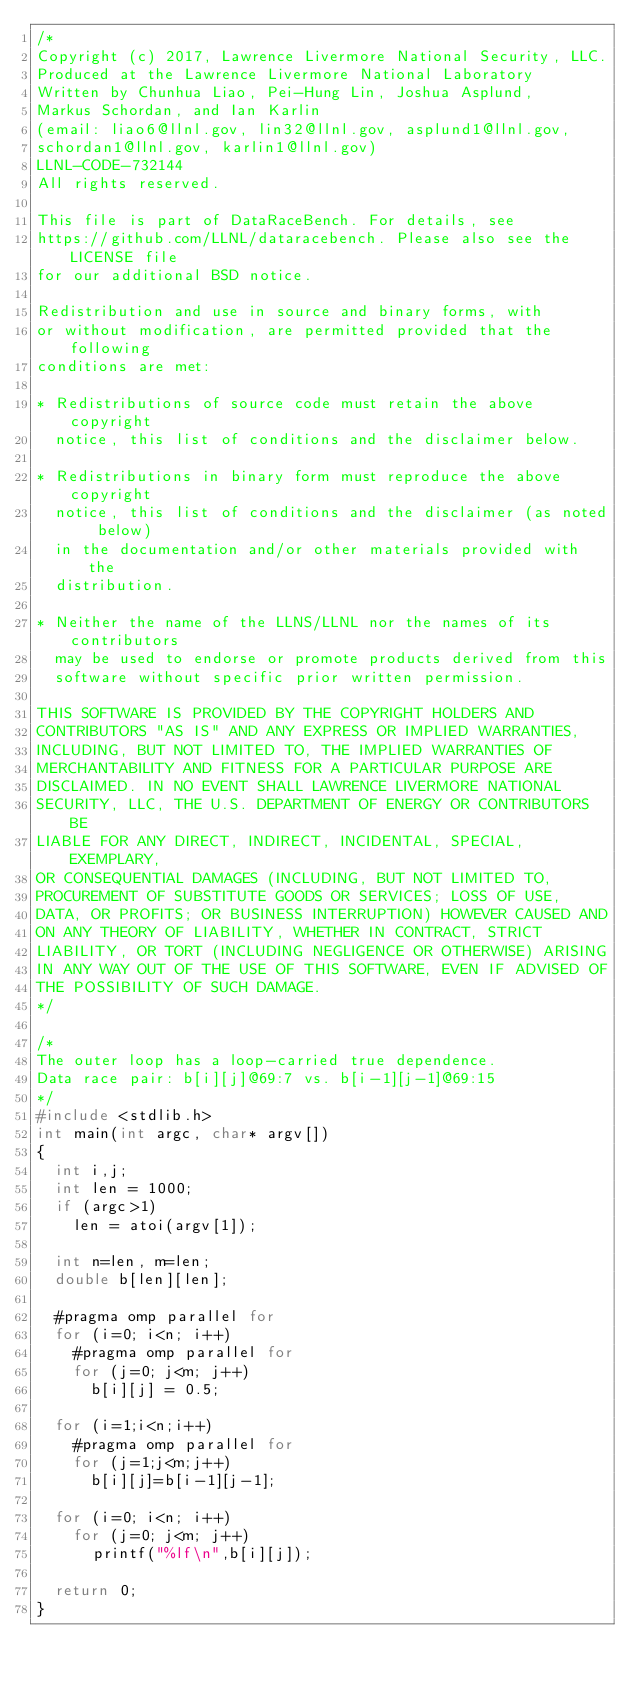Convert code to text. <code><loc_0><loc_0><loc_500><loc_500><_C_>/*
Copyright (c) 2017, Lawrence Livermore National Security, LLC.
Produced at the Lawrence Livermore National Laboratory
Written by Chunhua Liao, Pei-Hung Lin, Joshua Asplund,
Markus Schordan, and Ian Karlin
(email: liao6@llnl.gov, lin32@llnl.gov, asplund1@llnl.gov,
schordan1@llnl.gov, karlin1@llnl.gov)
LLNL-CODE-732144
All rights reserved.

This file is part of DataRaceBench. For details, see
https://github.com/LLNL/dataracebench. Please also see the LICENSE file
for our additional BSD notice.

Redistribution and use in source and binary forms, with
or without modification, are permitted provided that the following
conditions are met:

* Redistributions of source code must retain the above copyright
  notice, this list of conditions and the disclaimer below.

* Redistributions in binary form must reproduce the above copyright
  notice, this list of conditions and the disclaimer (as noted below)
  in the documentation and/or other materials provided with the
  distribution.

* Neither the name of the LLNS/LLNL nor the names of its contributors
  may be used to endorse or promote products derived from this
  software without specific prior written permission.

THIS SOFTWARE IS PROVIDED BY THE COPYRIGHT HOLDERS AND
CONTRIBUTORS "AS IS" AND ANY EXPRESS OR IMPLIED WARRANTIES,
INCLUDING, BUT NOT LIMITED TO, THE IMPLIED WARRANTIES OF
MERCHANTABILITY AND FITNESS FOR A PARTICULAR PURPOSE ARE
DISCLAIMED. IN NO EVENT SHALL LAWRENCE LIVERMORE NATIONAL
SECURITY, LLC, THE U.S. DEPARTMENT OF ENERGY OR CONTRIBUTORS BE
LIABLE FOR ANY DIRECT, INDIRECT, INCIDENTAL, SPECIAL, EXEMPLARY,
OR CONSEQUENTIAL DAMAGES (INCLUDING, BUT NOT LIMITED TO,
PROCUREMENT OF SUBSTITUTE GOODS OR SERVICES; LOSS OF USE,
DATA, OR PROFITS; OR BUSINESS INTERRUPTION) HOWEVER CAUSED AND
ON ANY THEORY OF LIABILITY, WHETHER IN CONTRACT, STRICT
LIABILITY, OR TORT (INCLUDING NEGLIGENCE OR OTHERWISE) ARISING
IN ANY WAY OUT OF THE USE OF THIS SOFTWARE, EVEN IF ADVISED OF
THE POSSIBILITY OF SUCH DAMAGE.
*/

/* 
The outer loop has a loop-carried true dependence.
Data race pair: b[i][j]@69:7 vs. b[i-1][j-1]@69:15
*/
#include <stdlib.h>
int main(int argc, char* argv[])
{
  int i,j;
  int len = 1000;
  if (argc>1)
    len = atoi(argv[1]);

  int n=len, m=len;
  double b[len][len];

  #pragma omp parallel for
  for (i=0; i<n; i++)
    #pragma omp parallel for
    for (j=0; j<m; j++)
      b[i][j] = 0.5; 
 
  for (i=1;i<n;i++)
    #pragma omp parallel for
    for (j=1;j<m;j++)
      b[i][j]=b[i-1][j-1];

  for (i=0; i<n; i++)
    for (j=0; j<m; j++)
      printf("%lf\n",b[i][j]);

  return 0;
}
</code> 